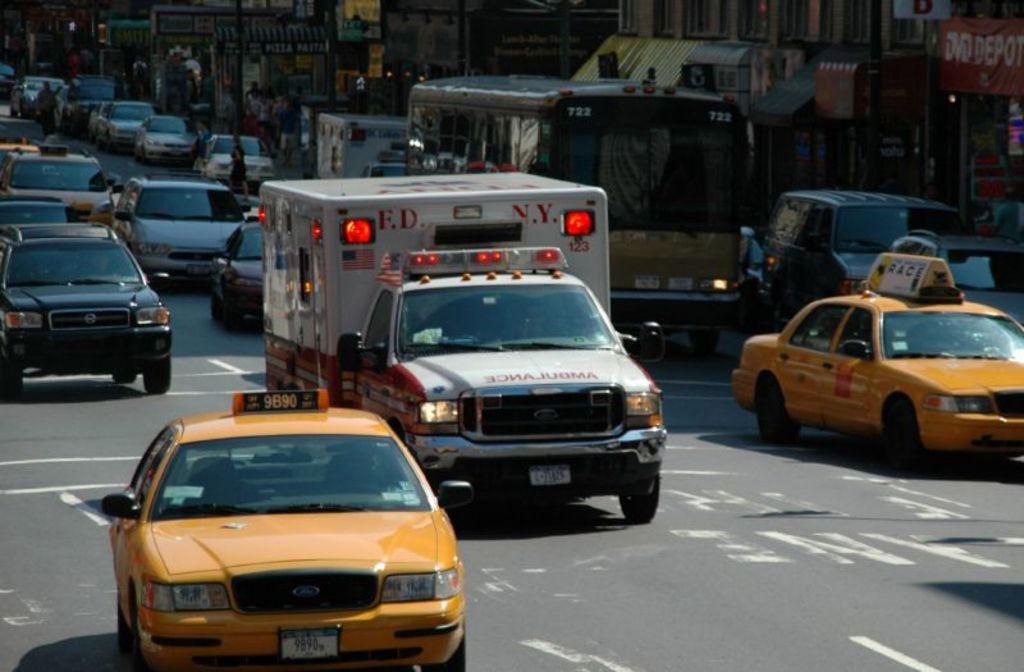Which state does this ambulance serve?
Offer a very short reply. New york. What is the licence plate number of the left taxi?
Keep it short and to the point. Unanswerable. 